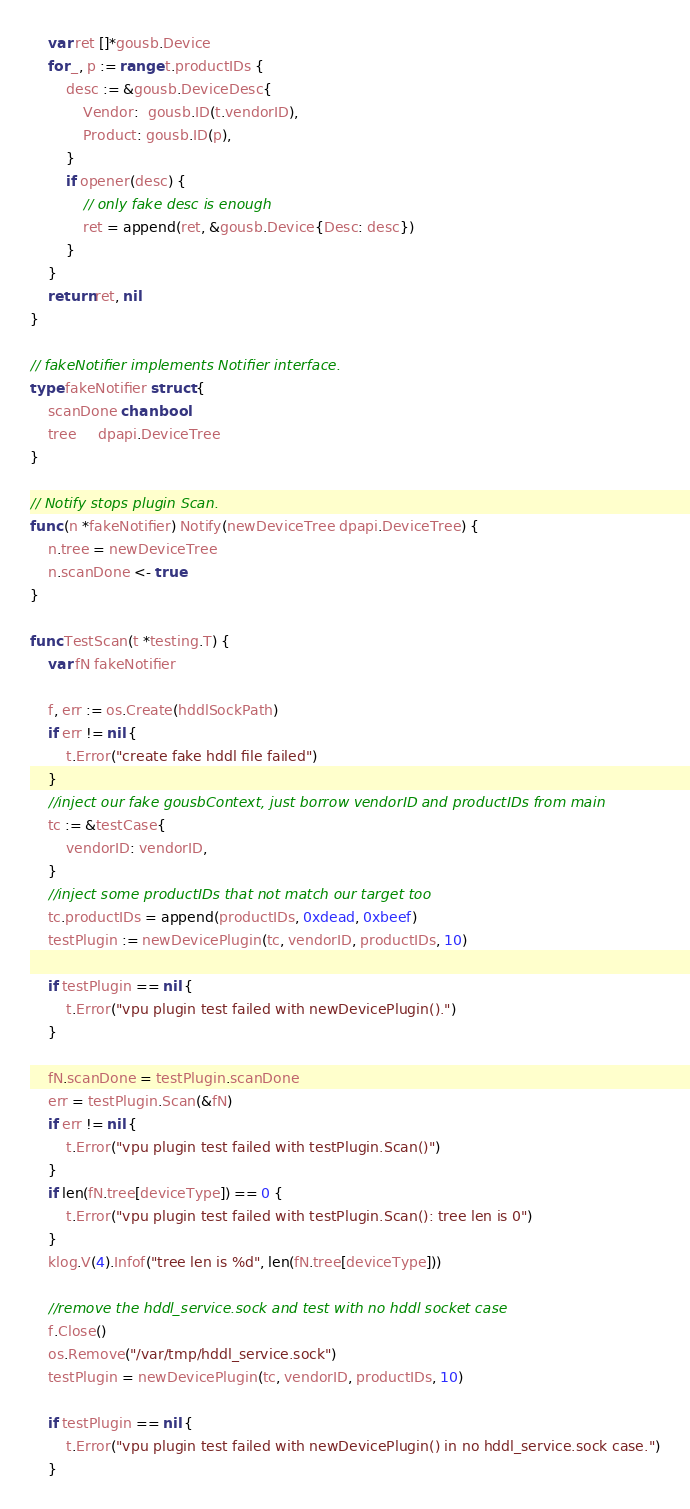Convert code to text. <code><loc_0><loc_0><loc_500><loc_500><_Go_>	var ret []*gousb.Device
	for _, p := range t.productIDs {
		desc := &gousb.DeviceDesc{
			Vendor:  gousb.ID(t.vendorID),
			Product: gousb.ID(p),
		}
		if opener(desc) {
			// only fake desc is enough
			ret = append(ret, &gousb.Device{Desc: desc})
		}
	}
	return ret, nil
}

// fakeNotifier implements Notifier interface.
type fakeNotifier struct {
	scanDone chan bool
	tree     dpapi.DeviceTree
}

// Notify stops plugin Scan.
func (n *fakeNotifier) Notify(newDeviceTree dpapi.DeviceTree) {
	n.tree = newDeviceTree
	n.scanDone <- true
}

func TestScan(t *testing.T) {
	var fN fakeNotifier

	f, err := os.Create(hddlSockPath)
	if err != nil {
		t.Error("create fake hddl file failed")
	}
	//inject our fake gousbContext, just borrow vendorID and productIDs from main
	tc := &testCase{
		vendorID: vendorID,
	}
	//inject some productIDs that not match our target too
	tc.productIDs = append(productIDs, 0xdead, 0xbeef)
	testPlugin := newDevicePlugin(tc, vendorID, productIDs, 10)

	if testPlugin == nil {
		t.Error("vpu plugin test failed with newDevicePlugin().")
	}

	fN.scanDone = testPlugin.scanDone
	err = testPlugin.Scan(&fN)
	if err != nil {
		t.Error("vpu plugin test failed with testPlugin.Scan()")
	}
	if len(fN.tree[deviceType]) == 0 {
		t.Error("vpu plugin test failed with testPlugin.Scan(): tree len is 0")
	}
	klog.V(4).Infof("tree len is %d", len(fN.tree[deviceType]))

	//remove the hddl_service.sock and test with no hddl socket case
	f.Close()
	os.Remove("/var/tmp/hddl_service.sock")
	testPlugin = newDevicePlugin(tc, vendorID, productIDs, 10)

	if testPlugin == nil {
		t.Error("vpu plugin test failed with newDevicePlugin() in no hddl_service.sock case.")
	}
</code> 